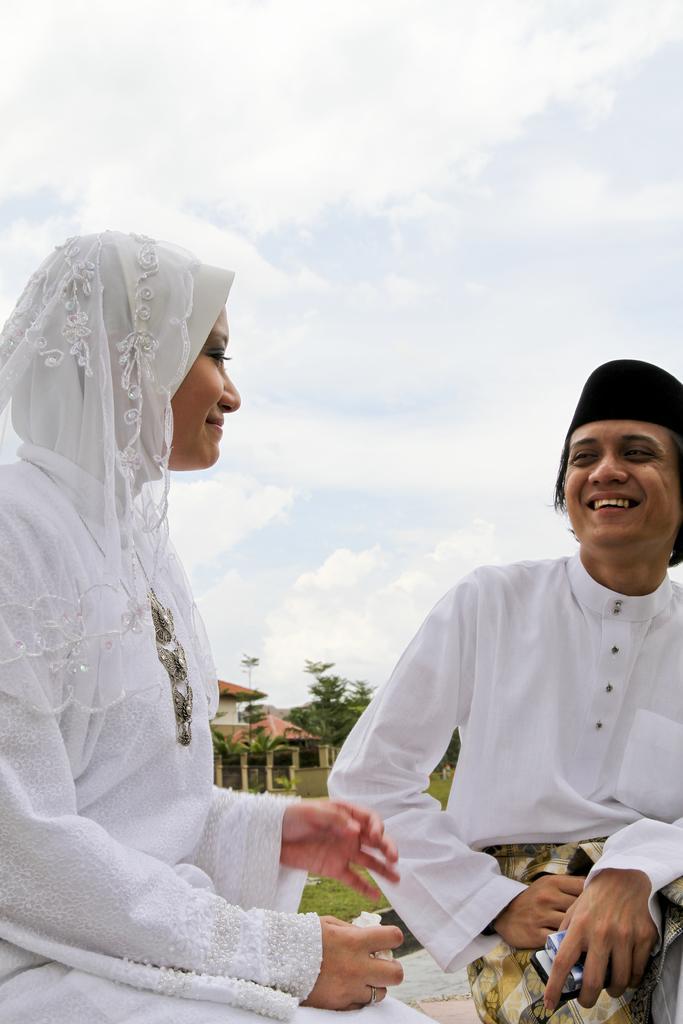Can you describe this image briefly? In the center of the image we can see man and woman sitting. In the background we can see house, trees, grass, sky and clouds. 